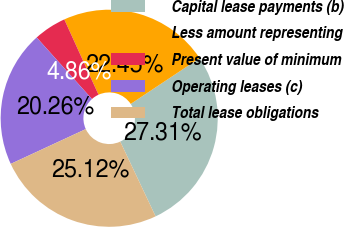<chart> <loc_0><loc_0><loc_500><loc_500><pie_chart><fcel>Capital lease payments (b)<fcel>Less amount representing<fcel>Present value of minimum<fcel>Operating leases (c)<fcel>Total lease obligations<nl><fcel>27.31%<fcel>22.45%<fcel>4.86%<fcel>20.26%<fcel>25.12%<nl></chart> 